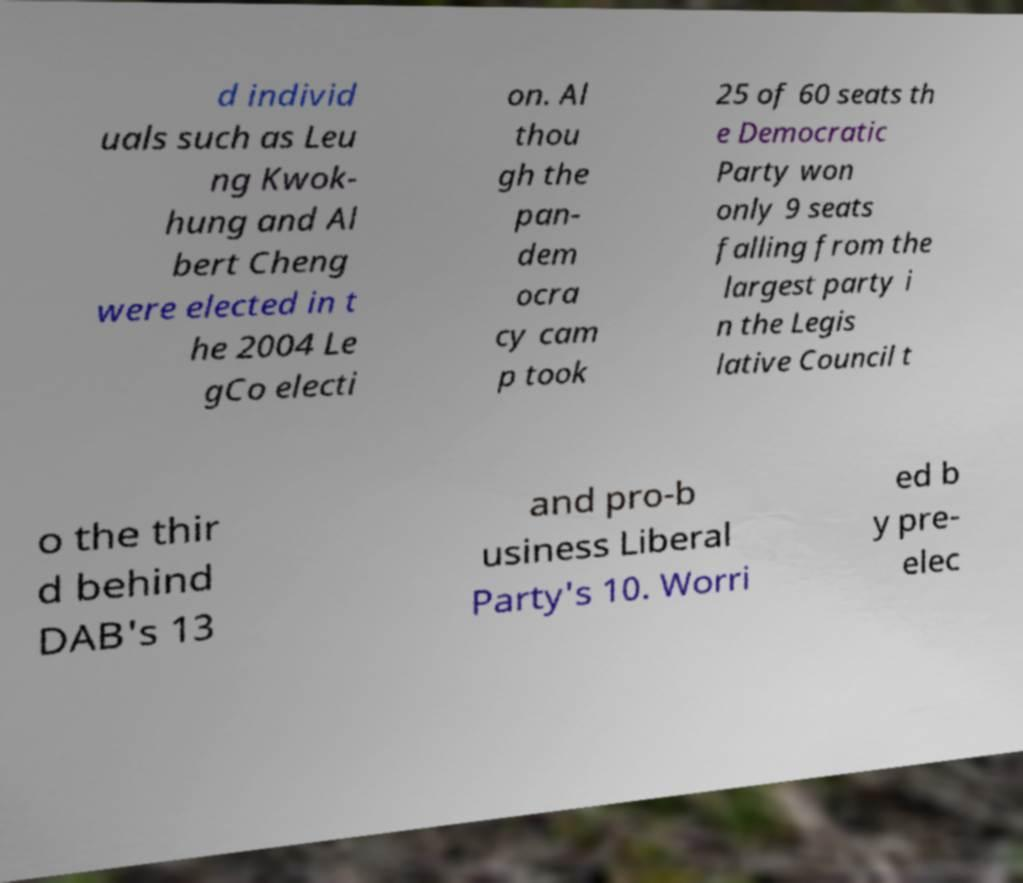Could you extract and type out the text from this image? d individ uals such as Leu ng Kwok- hung and Al bert Cheng were elected in t he 2004 Le gCo electi on. Al thou gh the pan- dem ocra cy cam p took 25 of 60 seats th e Democratic Party won only 9 seats falling from the largest party i n the Legis lative Council t o the thir d behind DAB's 13 and pro-b usiness Liberal Party's 10. Worri ed b y pre- elec 